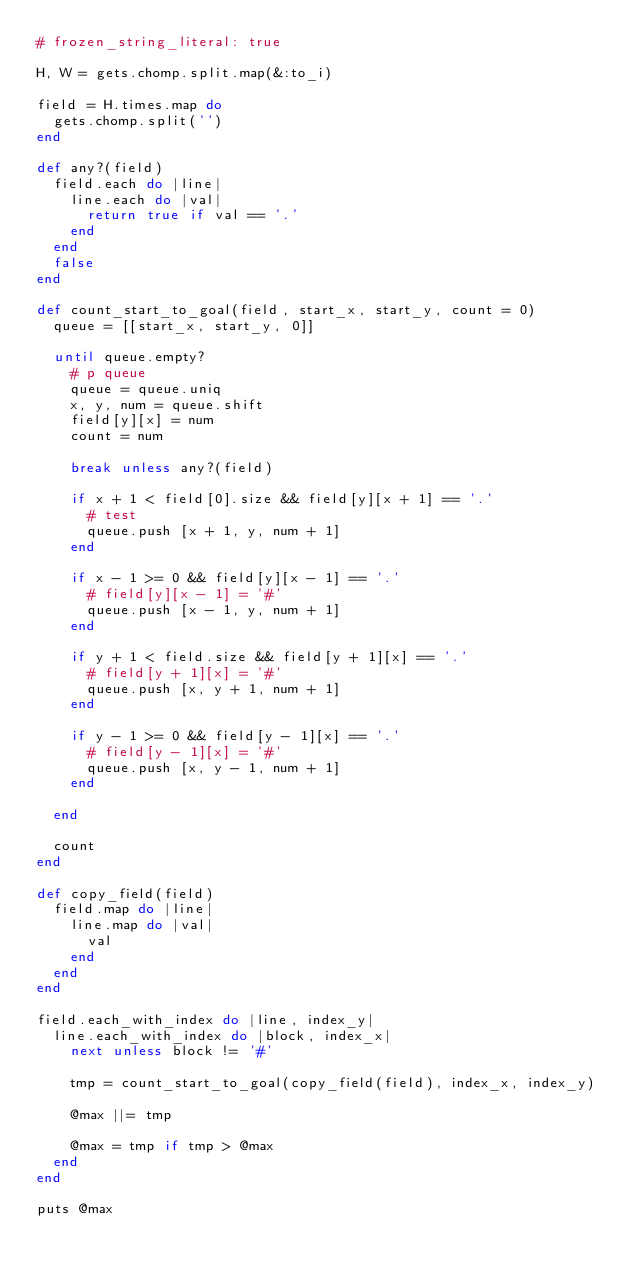<code> <loc_0><loc_0><loc_500><loc_500><_Ruby_># frozen_string_literal: true

H, W = gets.chomp.split.map(&:to_i)

field = H.times.map do
  gets.chomp.split('')
end

def any?(field)
  field.each do |line|
    line.each do |val|
      return true if val == '.'
    end
  end
  false
end

def count_start_to_goal(field, start_x, start_y, count = 0)
  queue = [[start_x, start_y, 0]]

  until queue.empty?
    # p queue
    queue = queue.uniq
    x, y, num = queue.shift
    field[y][x] = num
    count = num

    break unless any?(field)

    if x + 1 < field[0].size && field[y][x + 1] == '.'
      # test
      queue.push [x + 1, y, num + 1]
    end

    if x - 1 >= 0 && field[y][x - 1] == '.'
      # field[y][x - 1] = '#'
      queue.push [x - 1, y, num + 1]
    end

    if y + 1 < field.size && field[y + 1][x] == '.'
      # field[y + 1][x] = '#'
      queue.push [x, y + 1, num + 1]
    end

    if y - 1 >= 0 && field[y - 1][x] == '.'
      # field[y - 1][x] = '#'
      queue.push [x, y - 1, num + 1]
    end

  end

  count
end

def copy_field(field)
  field.map do |line|
    line.map do |val|
      val
    end
  end
end

field.each_with_index do |line, index_y|
  line.each_with_index do |block, index_x|
    next unless block != '#'

    tmp = count_start_to_goal(copy_field(field), index_x, index_y)

    @max ||= tmp

    @max = tmp if tmp > @max
  end
end

puts @max
</code> 